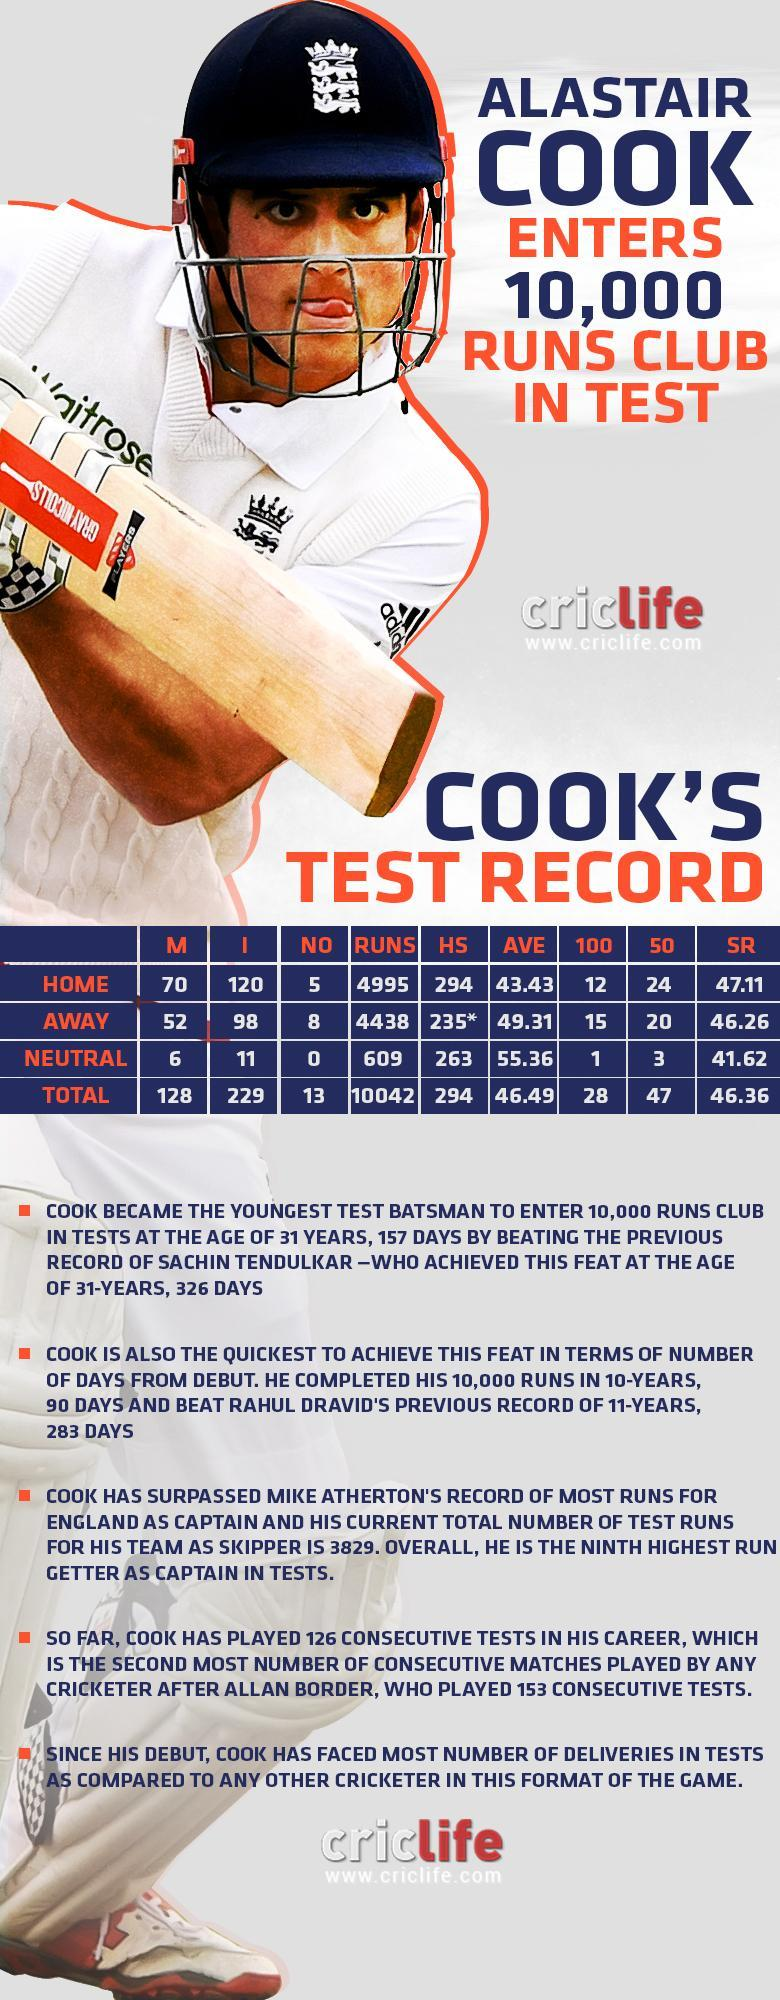What is the highest test score of Alastair Cook in home away matches?
Answer the question with a short phrase. 235* Which country did Alastair Cook play for? England What is the strike rate of Alastair Cook in home test matches? 47.11 What is the number of runs scored by Alastair Cook in home away test matches? 4438 How many 50s were scored by Alastair Cook in home test matches? 24 How many 100s were scored by Alastair Cook in home away test matches? 15 What is the highest test score of Alastair Cook in home matches? 294 What is the average score of Alastair Cook in home test matches? 43.43 What is the total number of test match innings played by Alastair Cook? 229 What is the total number of test matches played by Alastair Cook? 128 